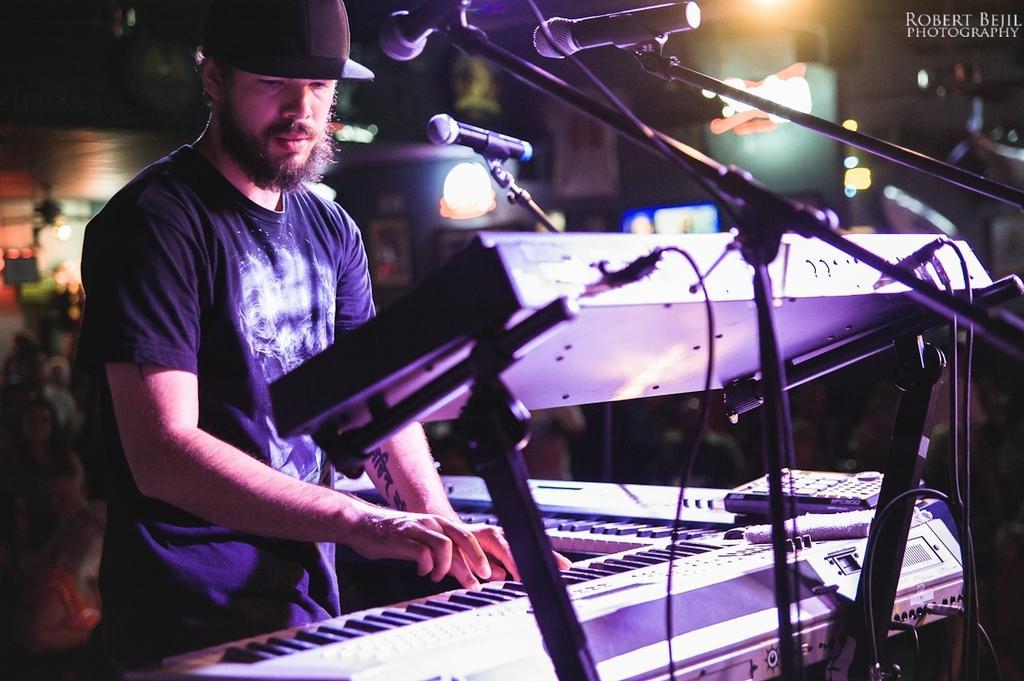Can you describe this image briefly? In this image there is a man standing. He is wearing a hat. In front of him there are musical keyboards. He is playing musical keyboards. There is a tattoo on his hand. In front of the keyboard there are microphones on the stands. Behind him there are people. The background is blurry. In the top right there is text on the image. 